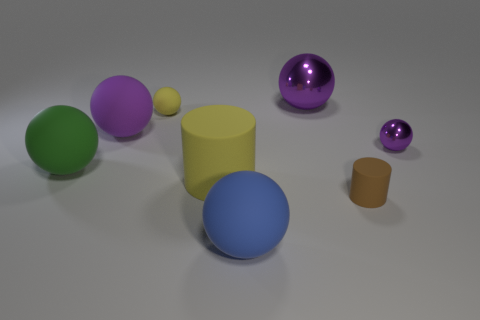Subtract all cyan blocks. How many purple balls are left? 3 Subtract 2 spheres. How many spheres are left? 4 Subtract all yellow spheres. How many spheres are left? 5 Subtract all tiny yellow balls. How many balls are left? 5 Subtract all cyan spheres. Subtract all gray cubes. How many spheres are left? 6 Add 1 tiny things. How many objects exist? 9 Subtract all spheres. How many objects are left? 2 Add 7 yellow things. How many yellow things are left? 9 Add 2 tiny cyan rubber blocks. How many tiny cyan rubber blocks exist? 2 Subtract 1 yellow balls. How many objects are left? 7 